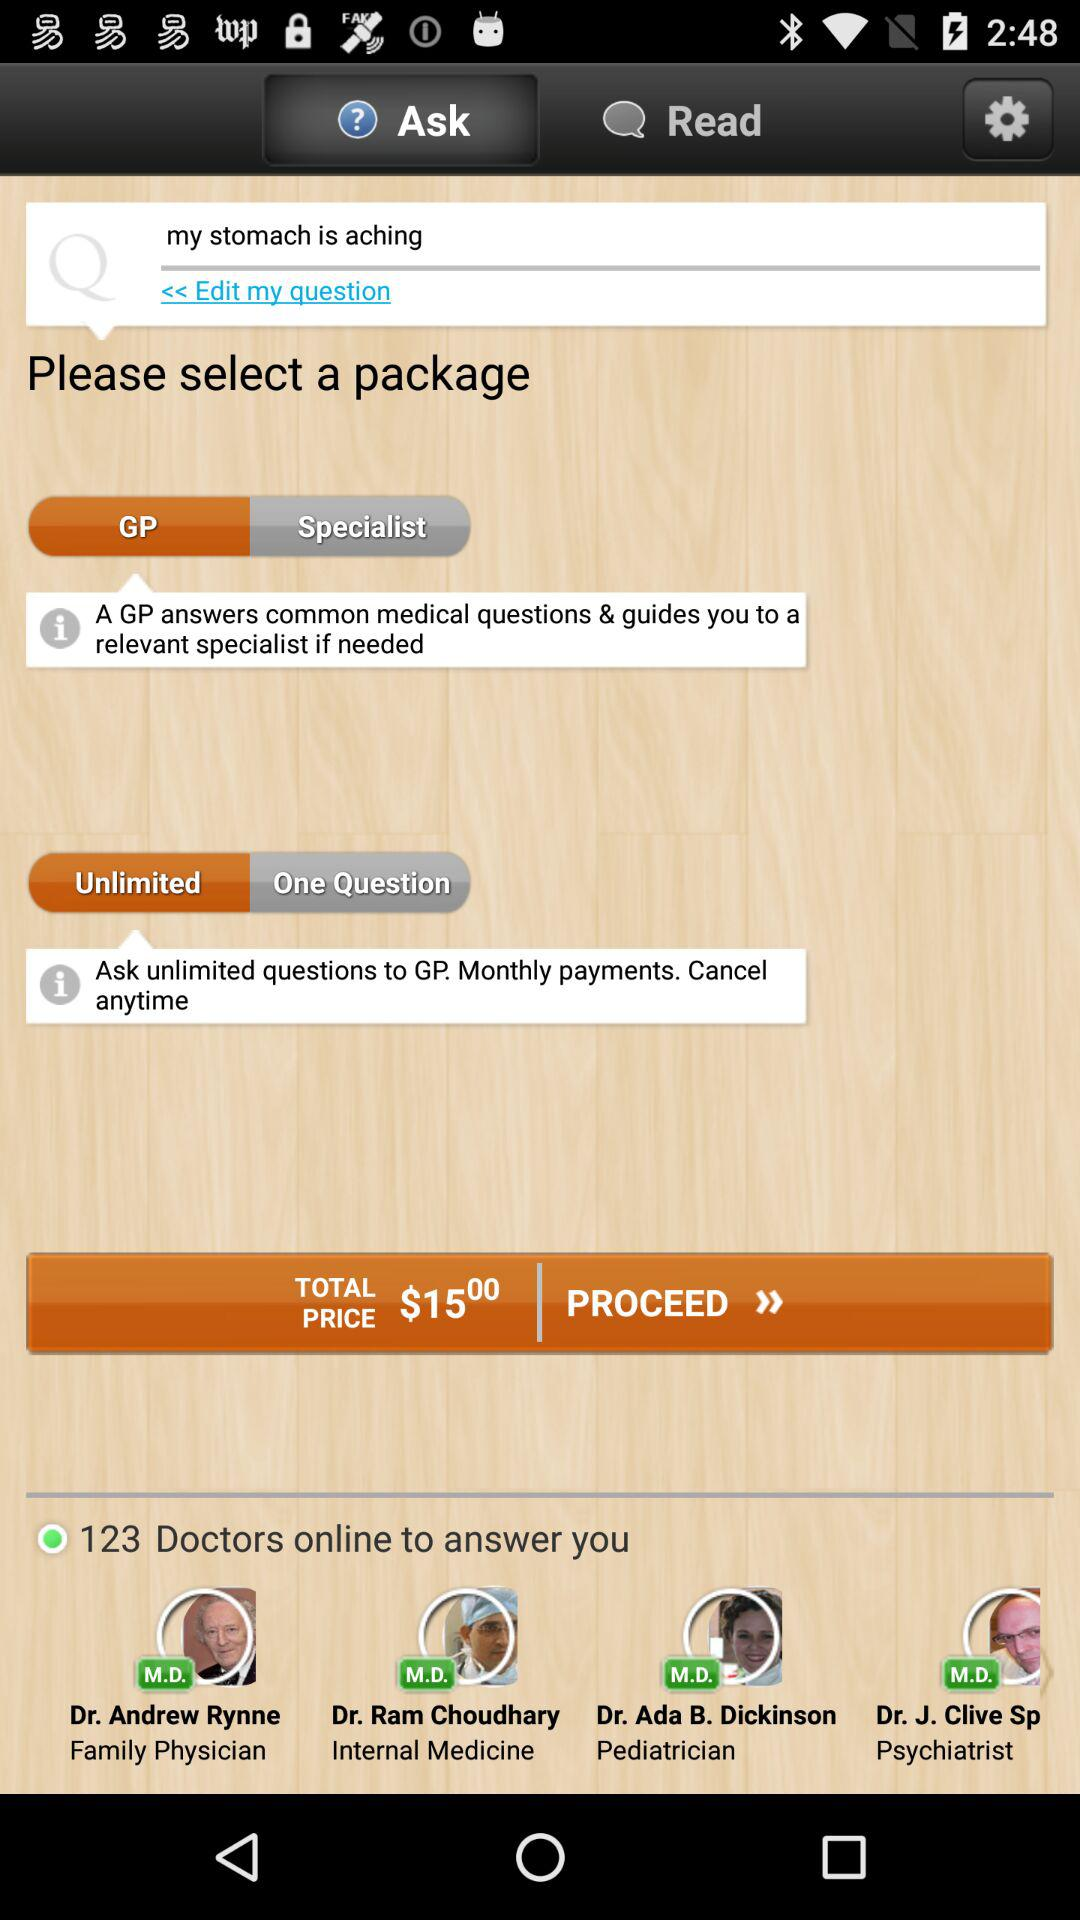How many doctors are available to answer my question?
Answer the question using a single word or phrase. 123 